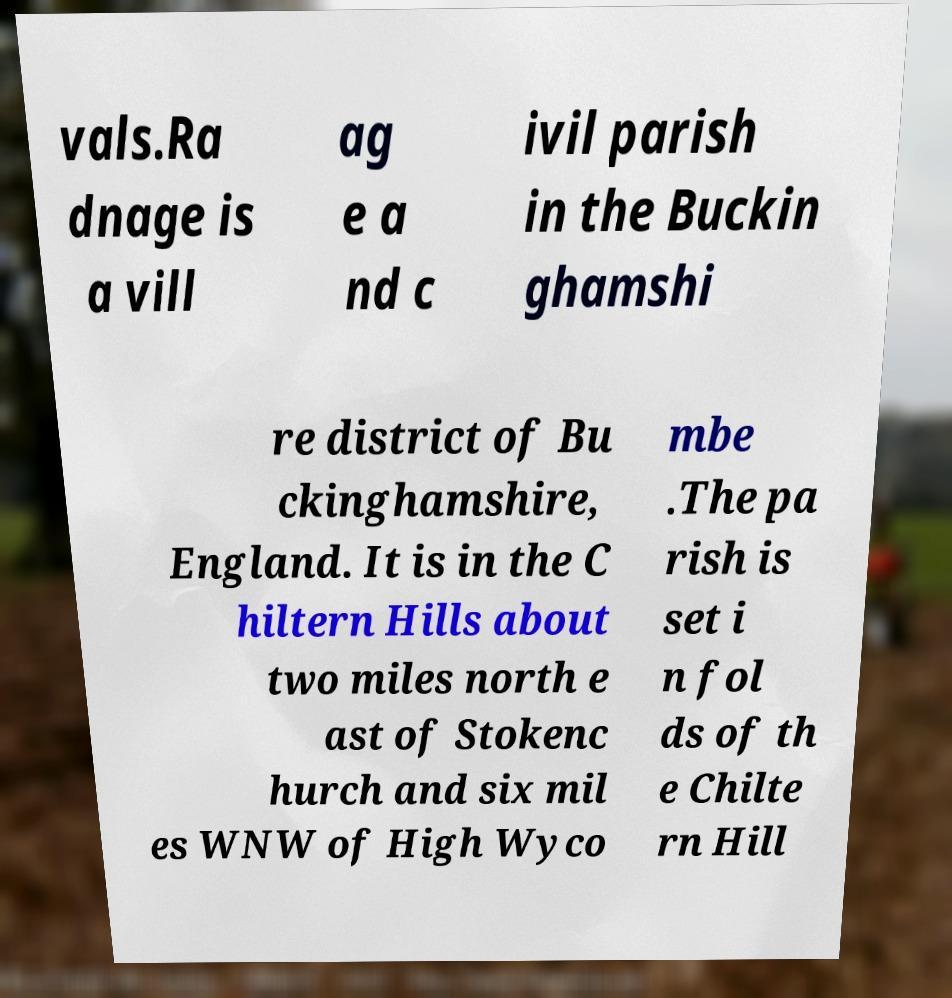Can you accurately transcribe the text from the provided image for me? vals.Ra dnage is a vill ag e a nd c ivil parish in the Buckin ghamshi re district of Bu ckinghamshire, England. It is in the C hiltern Hills about two miles north e ast of Stokenc hurch and six mil es WNW of High Wyco mbe .The pa rish is set i n fol ds of th e Chilte rn Hill 